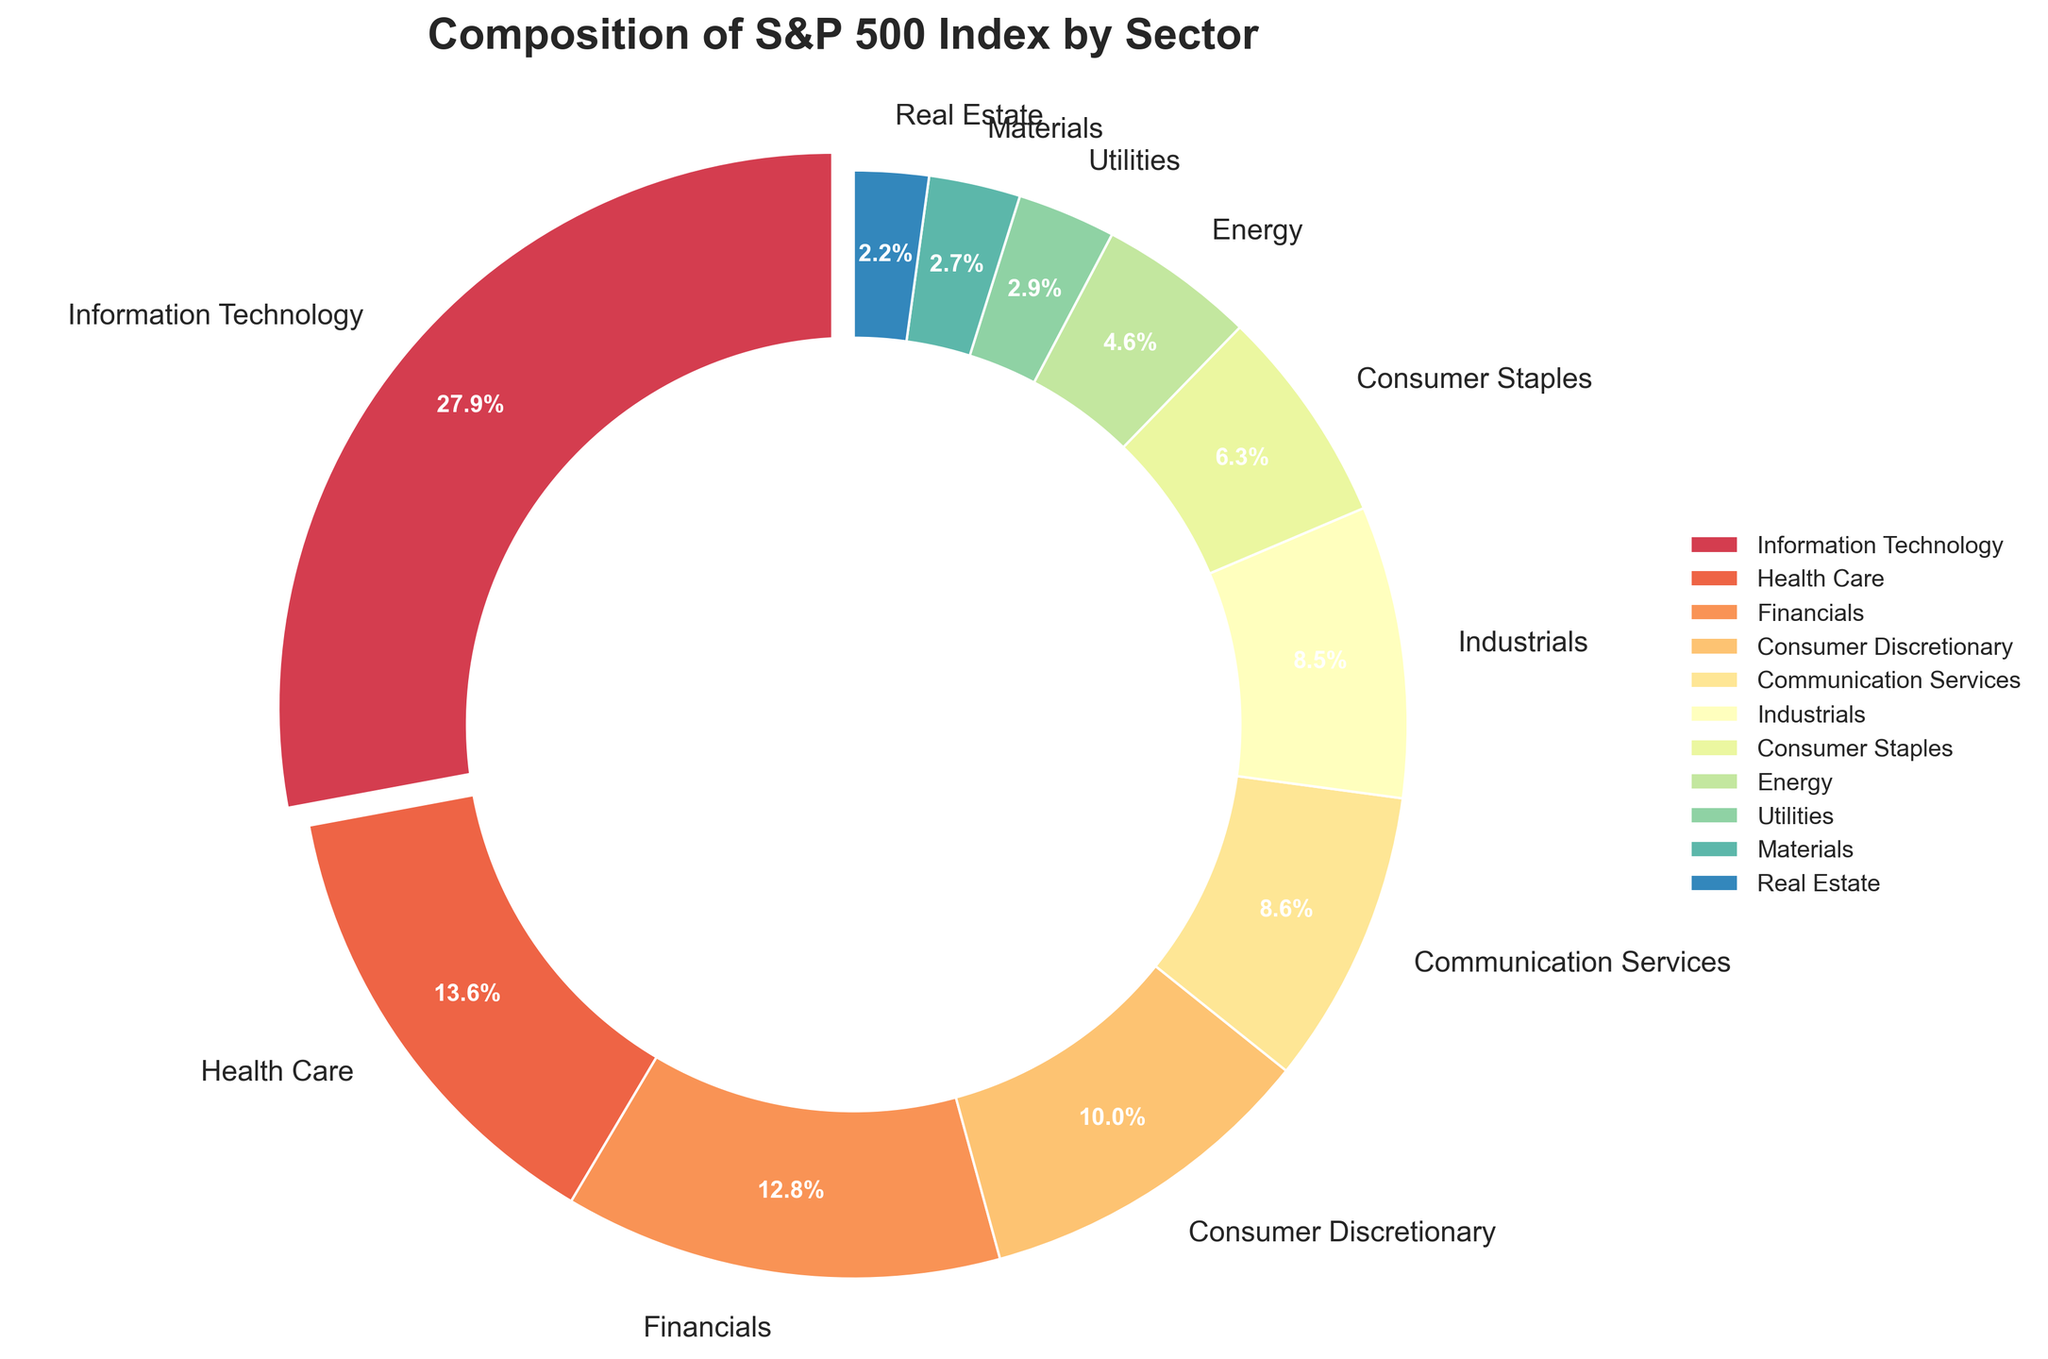Which sector has the highest percentage in the S&P 500 index? From the chart, we can see that each sector has a differently sized wedge, with the largest wedge belonging to Information Technology. The percentage next to Information Technology is 28.2%, the highest percentage.
Answer: Information Technology Which sector contributes more to the S&P 500 index, Health Care or Financials? By looking at the pie chart, we compare the wedges labeled Health Care and Financials. Health Care is labeled with 13.7%, and Financials is labeled with 12.9%. Therefore, Health Care has a higher percentage.
Answer: Health Care What is the combined percentage of Communication Services and Consumer Discretionary? We add the percentages of Communication Services and Consumer Discretionary. Communication Services has 8.7% and Consumer Discretionary has 10.1%. Adding these together gives 8.7 + 10.1 = 18.8%.
Answer: 18.8% Which sector has a larger share: Utilities or Real Estate? We compare the wedges labeled Utilities and Real Estate. Utilities is labeled with 2.9%, and Real Estate is labeled with 2.2%. Therefore, Utilities has a larger share.
Answer: Utilities What is the total percentage of the top three sectors? The top three sectors by percentage are Information Technology (28.2%), Health Care (13.7%), and Financials (12.9%). Adding these percentages together gives 28.2 + 13.7 + 12.9 = 54.8%.
Answer: 54.8% If the combined percentage of Consumer Staples and Energy equals 11%, is this true? We add the percentages of Consumer Staples and Energy. Consumer Staples has 6.4% and Energy has 4.6%. Adding these together gives 6.4 + 4.6 = 11%, confirming the statement.
Answer: Yes Which sector is represented by the smallest wedge in the pie chart? By visually inspecting the pie chart, the smallest wedge corresponds to the sector labeled Real Estate, which has a percentage of 2.2%.
Answer: Real Estate How many sectors have a percentage greater than 10%? We identify the sectors with percentages greater than 10% by looking at the labels. Information Technology (28.2%), Health Care (13.7%), Financials (12.9%), and Consumer Discretionary (10.1%) are greater than 10%. Counting these sectors gives us four sectors.
Answer: 4 Compare the shares of the Energy sector and Materials sector. Which one has a higher percentage and by how much? Comparing the wedges labeled Energy (4.6%) and Materials (2.7%), we see that Energy has a higher percentage. The difference is 4.6 - 2.7 = 1.9%.
Answer: Energy by 1.9% 